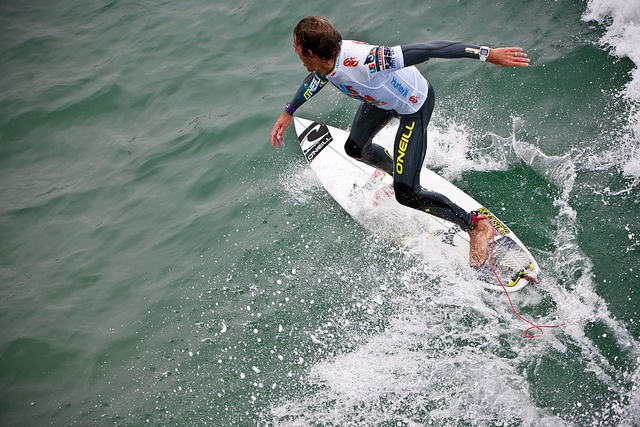Describe the objects in this image and their specific colors. I can see people in black, lavender, darkgray, and gray tones and surfboard in black, lightgray, darkgray, and gray tones in this image. 